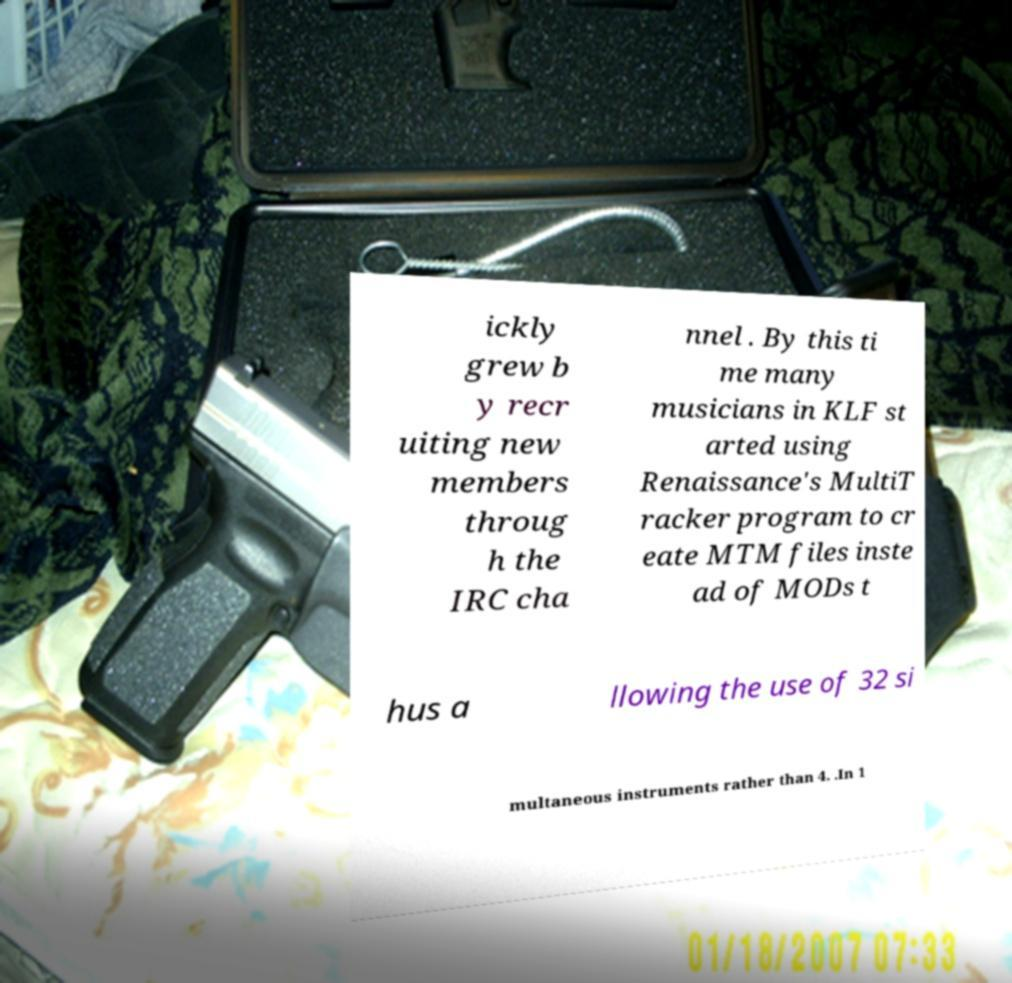What messages or text are displayed in this image? I need them in a readable, typed format. ickly grew b y recr uiting new members throug h the IRC cha nnel . By this ti me many musicians in KLF st arted using Renaissance's MultiT racker program to cr eate MTM files inste ad of MODs t hus a llowing the use of 32 si multaneous instruments rather than 4. .In 1 